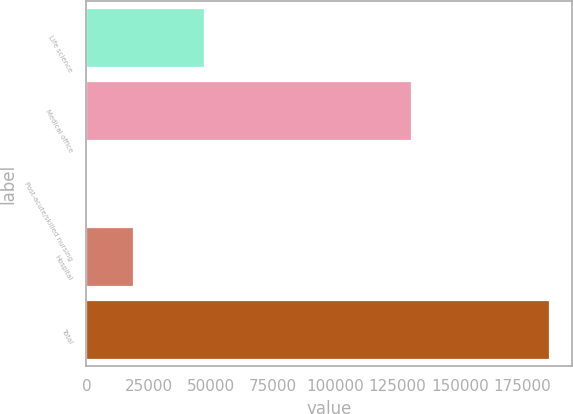Convert chart. <chart><loc_0><loc_0><loc_500><loc_500><bar_chart><fcel>Life science<fcel>Medical office<fcel>Post-acute/skilled nursing<fcel>Hospital<fcel>Total<nl><fcel>47285<fcel>130476<fcel>135<fcel>18691.9<fcel>185704<nl></chart> 